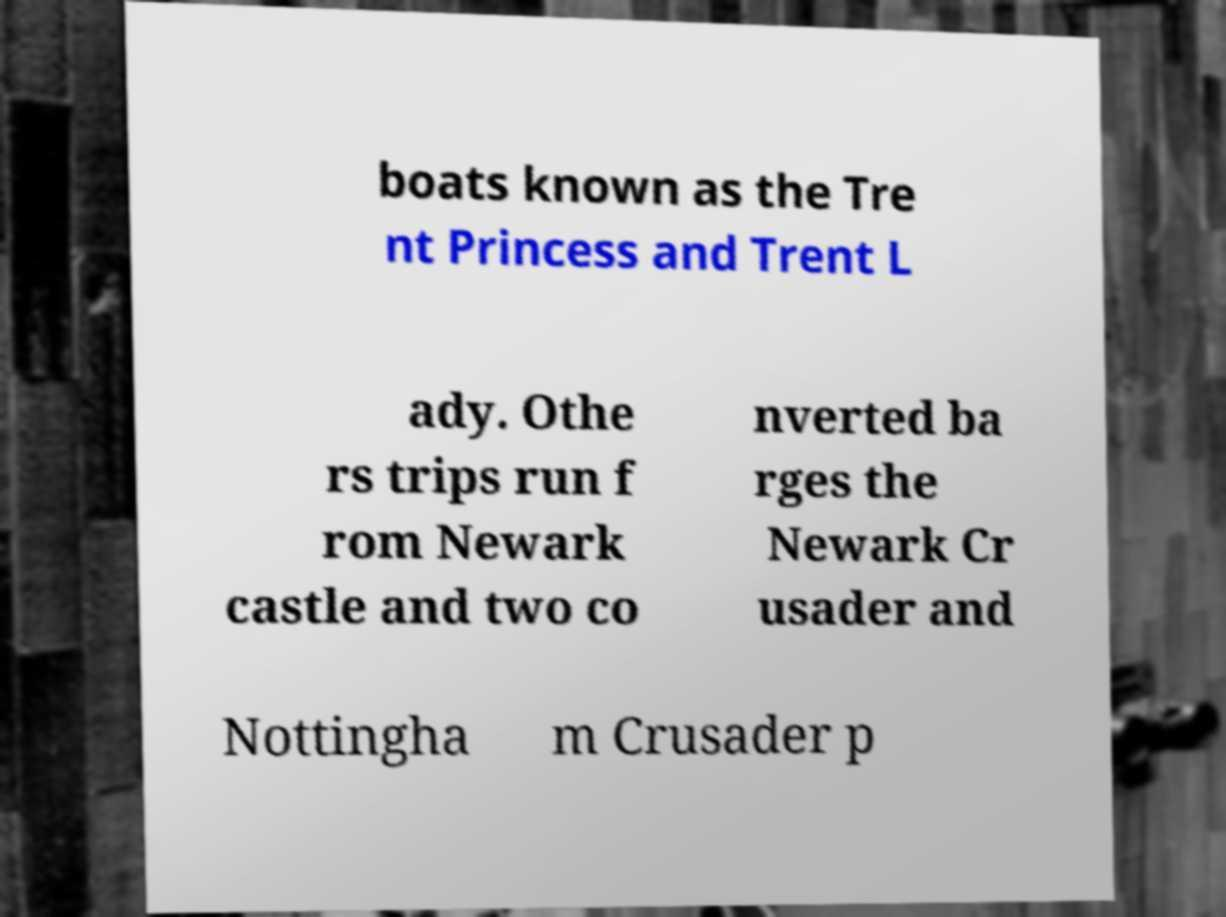Please read and relay the text visible in this image. What does it say? boats known as the Tre nt Princess and Trent L ady. Othe rs trips run f rom Newark castle and two co nverted ba rges the Newark Cr usader and Nottingha m Crusader p 